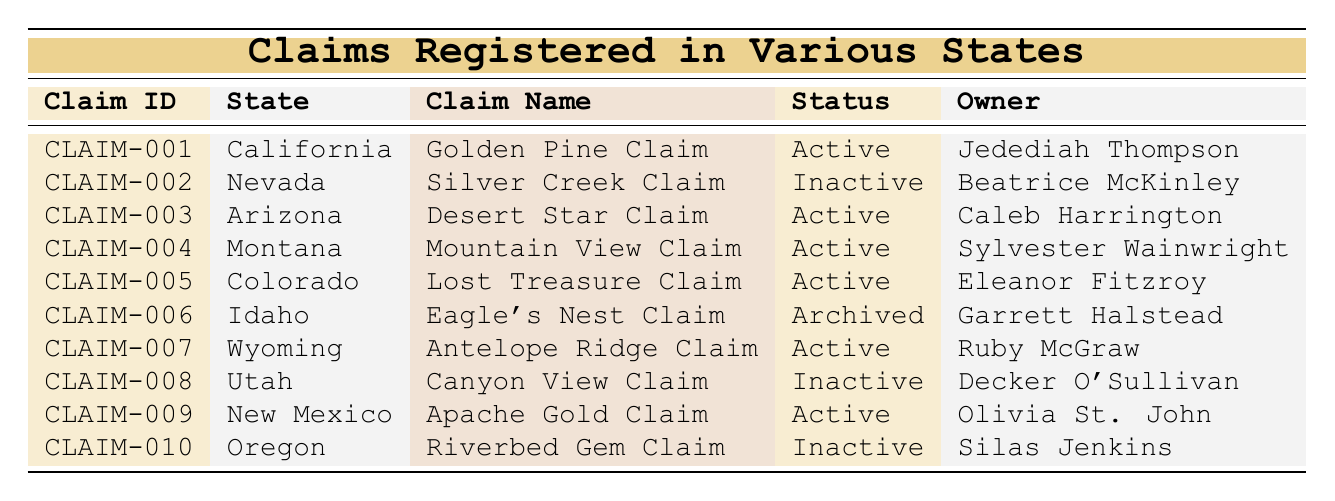What is the name of the claim registered in California? Referring to the table, the claim registered in California is listed under the "State" column. It shows that the claim name for California is "Golden Pine Claim."
Answer: Golden Pine Claim How many claims are currently marked as Active? By counting the entries in the "Status" column, there are 5 claims with the status of "Active." Specifically, these are claims 001, 003, 004, 005, 007, and 009.
Answer: 5 Is the "Silver Creek Claim" active or inactive? Looking at the table, the "Silver Creek Claim" is under Nevada with a status of "Inactive."
Answer: Inactive What is the claim type of the "Antelope Ridge Claim"? The table shows that the "Antelope Ridge Claim," located in Wyoming, is classified as a "Lode" type claim in the "Type" column.
Answer: Lode Which claim has the longest time since registration? To determine the claim with the longest time since registration, we compare the "date registered" values. The "Eagle's Nest Claim" registered the earliest on 2019-11-14. However, for claims still active, "Lost Treasure Claim" registered on 2020-09-30 is still valid. Between inactive claims, "Silver Creek Claim" was registered on 2021-03-22, and "Riverbed Gem Claim" was registered on 2020-12-05. Therefore, the claim with the longest registration prior to present, specifically amongst the still active claims is the "Eagle's Nest Claim."
Answer: Eagle's Nest Claim How many states have claims that are currently inactive? The table identifies two claims marked as inactive, specifically in Nevada and Utah. Therefore, only those two states have claims that are currently inactive.
Answer: 2 